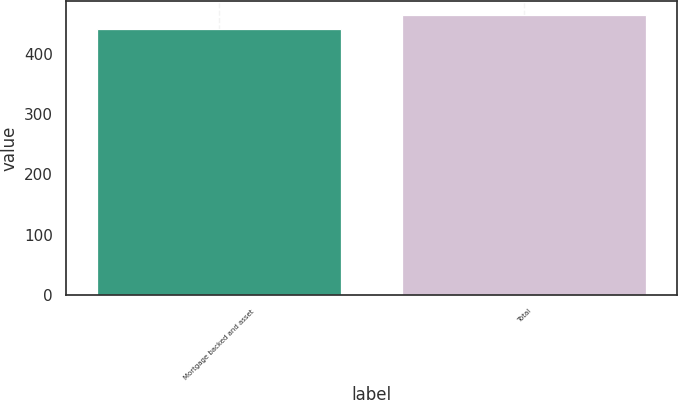Convert chart to OTSL. <chart><loc_0><loc_0><loc_500><loc_500><bar_chart><fcel>Mortgage backed and asset<fcel>Total<nl><fcel>440<fcel>464<nl></chart> 